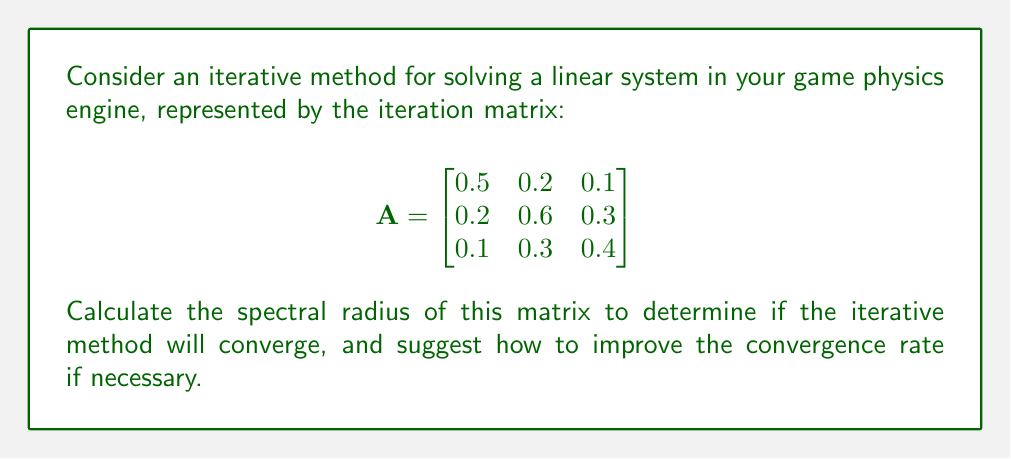Provide a solution to this math problem. To evaluate the spectral radius and determine convergence:

1. Find the eigenvalues of matrix A:
   Characteristic equation: $\det(A - \lambda I) = 0$
   $\begin{vmatrix}
   0.5-\lambda & 0.2 & 0.1 \\
   0.2 & 0.6-\lambda & 0.3 \\
   0.1 & 0.3 & 0.4-\lambda
   \end{vmatrix} = 0$

2. Solve the equation:
   $-\lambda^3 + 1.5\lambda^2 - 0.71\lambda + 0.104 = 0$

3. Using a numerical method (e.g., Newton-Raphson), find the roots:
   $\lambda_1 \approx 0.9053$
   $\lambda_2 \approx 0.3973$
   $\lambda_3 \approx 0.1974$

4. The spectral radius $\rho(A)$ is the maximum absolute eigenvalue:
   $\rho(A) = \max(|\lambda_1|, |\lambda_2|, |\lambda_3|) \approx 0.9053$

5. For convergence, we need $\rho(A) < 1$. Since $0.9053 < 1$, the method will converge.

6. To improve convergence rate:
   - Use relaxation techniques (e.g., SOR method)
   - Apply preconditioning to reduce the condition number
   - Implement more advanced iterative methods (e.g., GMRES, Conjugate Gradient)
Answer: $\rho(A) \approx 0.9053$; convergent but slow 